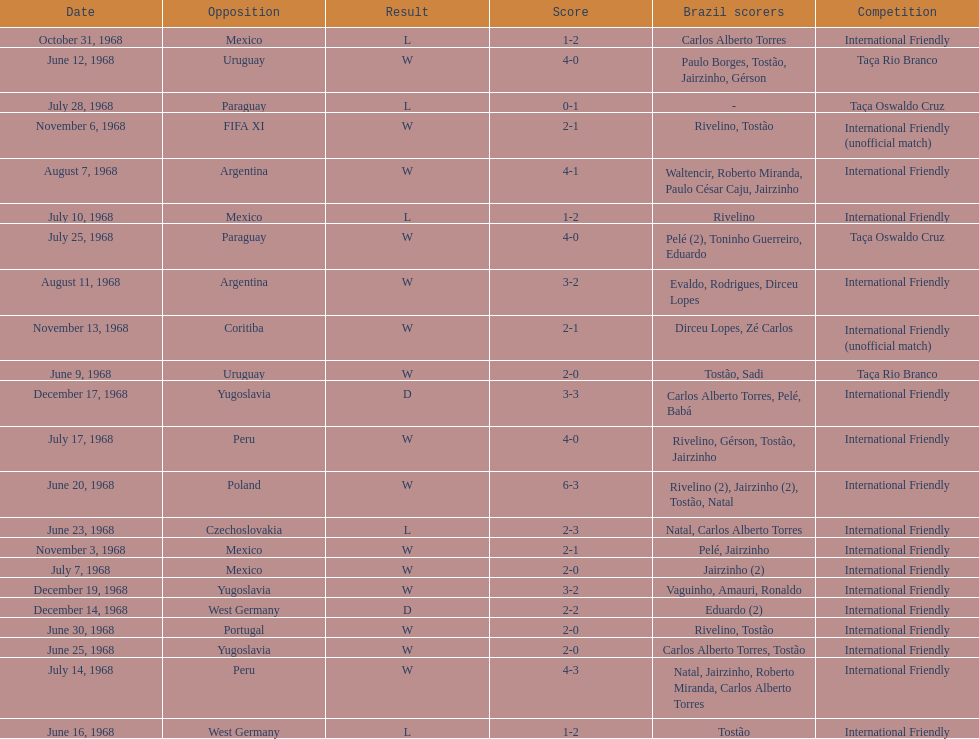The most goals scored by brazil in a game 6. Could you parse the entire table? {'header': ['Date', 'Opposition', 'Result', 'Score', 'Brazil scorers', 'Competition'], 'rows': [['October 31, 1968', 'Mexico', 'L', '1-2', 'Carlos Alberto Torres', 'International Friendly'], ['June 12, 1968', 'Uruguay', 'W', '4-0', 'Paulo Borges, Tostão, Jairzinho, Gérson', 'Taça Rio Branco'], ['July 28, 1968', 'Paraguay', 'L', '0-1', '-', 'Taça Oswaldo Cruz'], ['November 6, 1968', 'FIFA XI', 'W', '2-1', 'Rivelino, Tostão', 'International Friendly (unofficial match)'], ['August 7, 1968', 'Argentina', 'W', '4-1', 'Waltencir, Roberto Miranda, Paulo César Caju, Jairzinho', 'International Friendly'], ['July 10, 1968', 'Mexico', 'L', '1-2', 'Rivelino', 'International Friendly'], ['July 25, 1968', 'Paraguay', 'W', '4-0', 'Pelé (2), Toninho Guerreiro, Eduardo', 'Taça Oswaldo Cruz'], ['August 11, 1968', 'Argentina', 'W', '3-2', 'Evaldo, Rodrigues, Dirceu Lopes', 'International Friendly'], ['November 13, 1968', 'Coritiba', 'W', '2-1', 'Dirceu Lopes, Zé Carlos', 'International Friendly (unofficial match)'], ['June 9, 1968', 'Uruguay', 'W', '2-0', 'Tostão, Sadi', 'Taça Rio Branco'], ['December 17, 1968', 'Yugoslavia', 'D', '3-3', 'Carlos Alberto Torres, Pelé, Babá', 'International Friendly'], ['July 17, 1968', 'Peru', 'W', '4-0', 'Rivelino, Gérson, Tostão, Jairzinho', 'International Friendly'], ['June 20, 1968', 'Poland', 'W', '6-3', 'Rivelino (2), Jairzinho (2), Tostão, Natal', 'International Friendly'], ['June 23, 1968', 'Czechoslovakia', 'L', '2-3', 'Natal, Carlos Alberto Torres', 'International Friendly'], ['November 3, 1968', 'Mexico', 'W', '2-1', 'Pelé, Jairzinho', 'International Friendly'], ['July 7, 1968', 'Mexico', 'W', '2-0', 'Jairzinho (2)', 'International Friendly'], ['December 19, 1968', 'Yugoslavia', 'W', '3-2', 'Vaguinho, Amauri, Ronaldo', 'International Friendly'], ['December 14, 1968', 'West Germany', 'D', '2-2', 'Eduardo (2)', 'International Friendly'], ['June 30, 1968', 'Portugal', 'W', '2-0', 'Rivelino, Tostão', 'International Friendly'], ['June 25, 1968', 'Yugoslavia', 'W', '2-0', 'Carlos Alberto Torres, Tostão', 'International Friendly'], ['July 14, 1968', 'Peru', 'W', '4-3', 'Natal, Jairzinho, Roberto Miranda, Carlos Alberto Torres', 'International Friendly'], ['June 16, 1968', 'West Germany', 'L', '1-2', 'Tostão', 'International Friendly']]} 